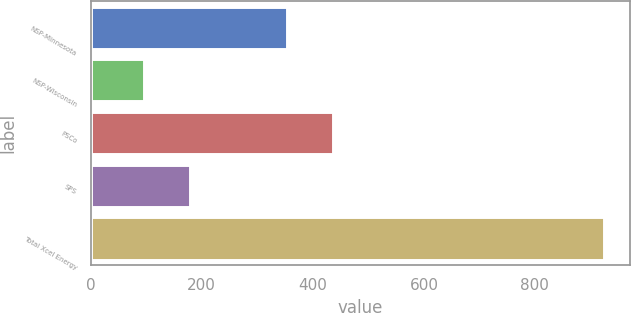<chart> <loc_0><loc_0><loc_500><loc_500><bar_chart><fcel>NSP-Minnesota<fcel>NSP-Wisconsin<fcel>PSCo<fcel>SPS<fcel>Total Xcel Energy<nl><fcel>354<fcel>96<fcel>436.9<fcel>178.9<fcel>925<nl></chart> 